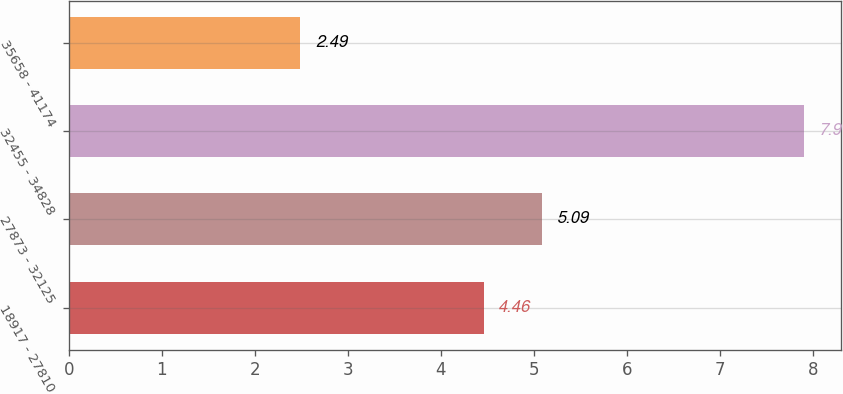Convert chart to OTSL. <chart><loc_0><loc_0><loc_500><loc_500><bar_chart><fcel>18917 - 27810<fcel>27873 - 32125<fcel>32455 - 34828<fcel>35658 - 41174<nl><fcel>4.46<fcel>5.09<fcel>7.9<fcel>2.49<nl></chart> 